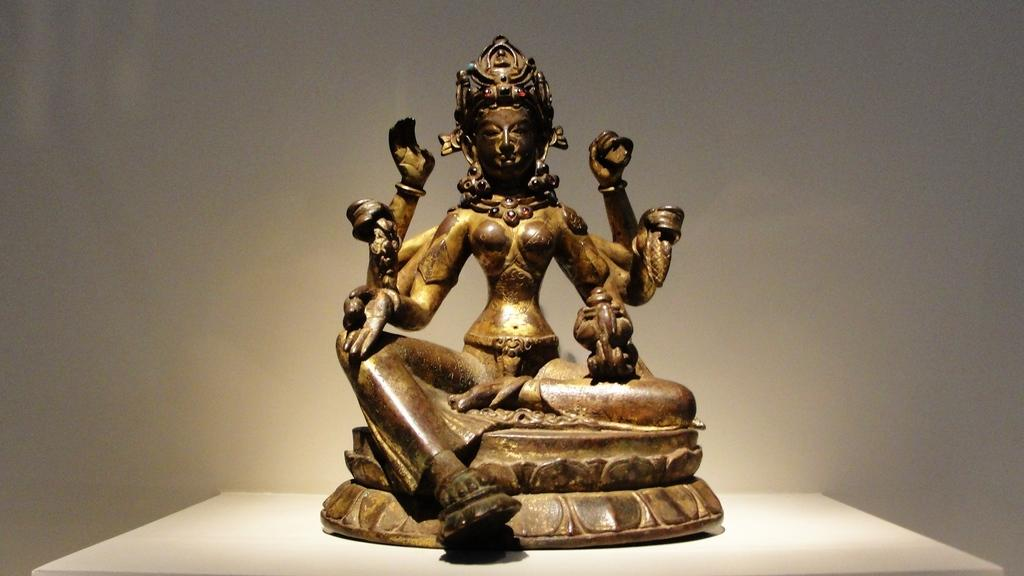What is the main subject of the image? There is a statue in the image. What is the statue standing on? The statue is on a white surface. What color is the background of the image? The background of the image is white. What type of heart is visible in the frame of the image? There is no heart or frame present in the image; it features a statue on a white surface with a white background. 